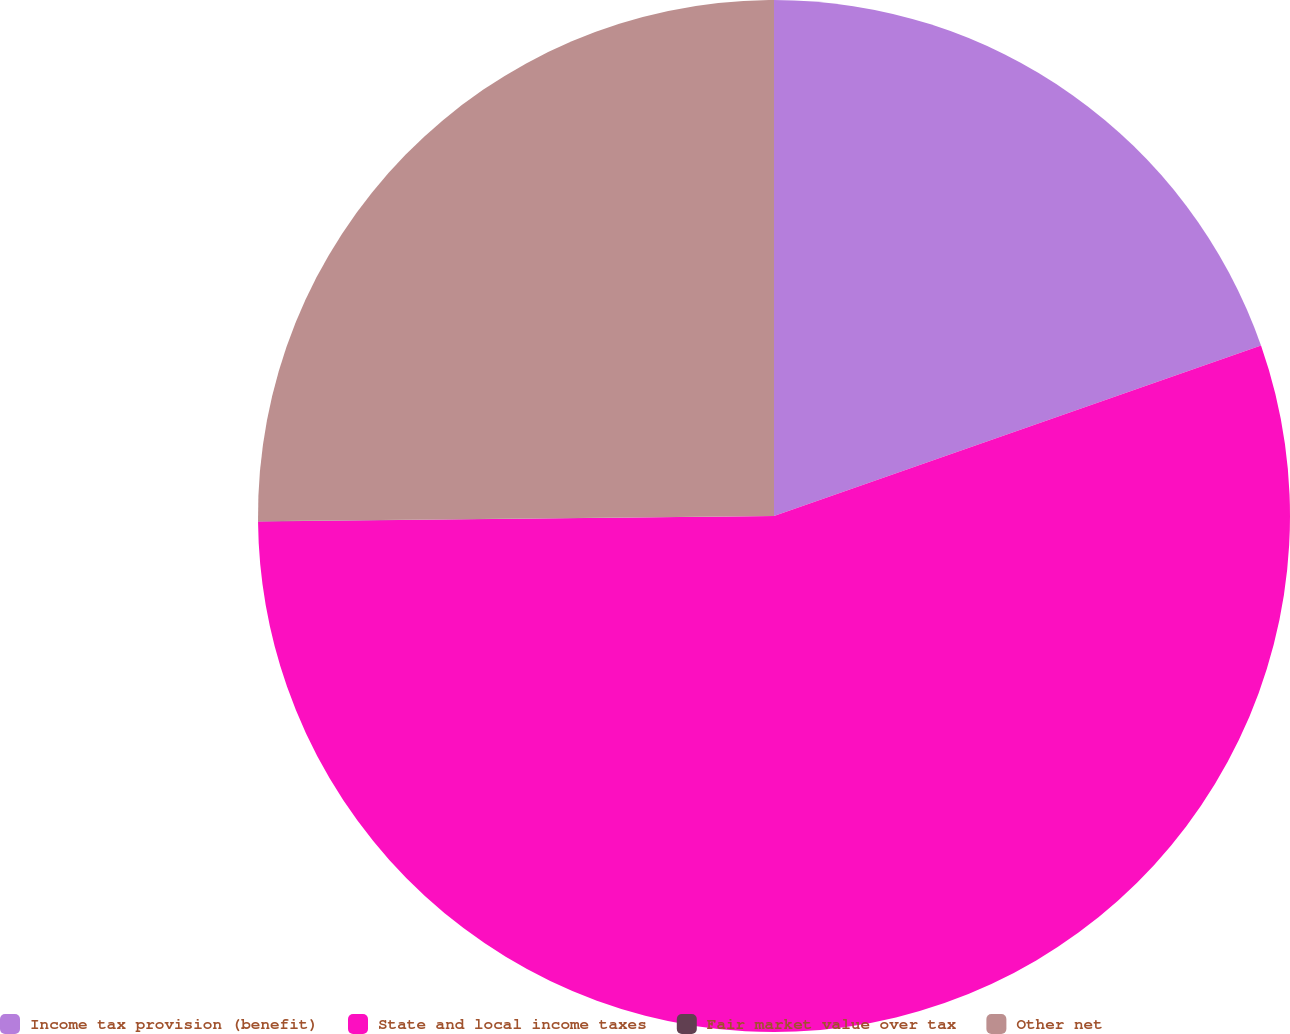Convert chart. <chart><loc_0><loc_0><loc_500><loc_500><pie_chart><fcel>Income tax provision (benefit)<fcel>State and local income taxes<fcel>Fair market value over tax<fcel>Other net<nl><fcel>19.64%<fcel>55.19%<fcel>0.01%<fcel>25.16%<nl></chart> 